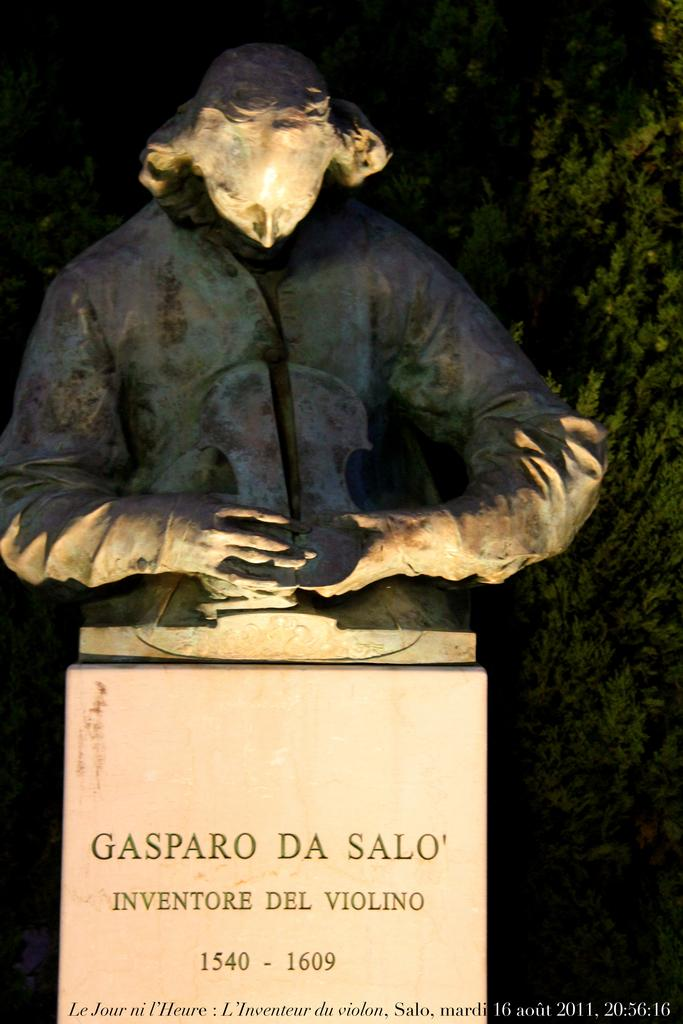What type of figure can be seen in the image? There is a human statue in the image. What is present on the wall in the image? There is writing on the wall in the image. Can you see any boats in the harbor in the image? There is no harbor or boats present in the image; it features a human statue and writing on a wall. What type of animals can be seen on the farm in the image? There is no farm or animals present in the image; it features a human statue and writing on a wall. 